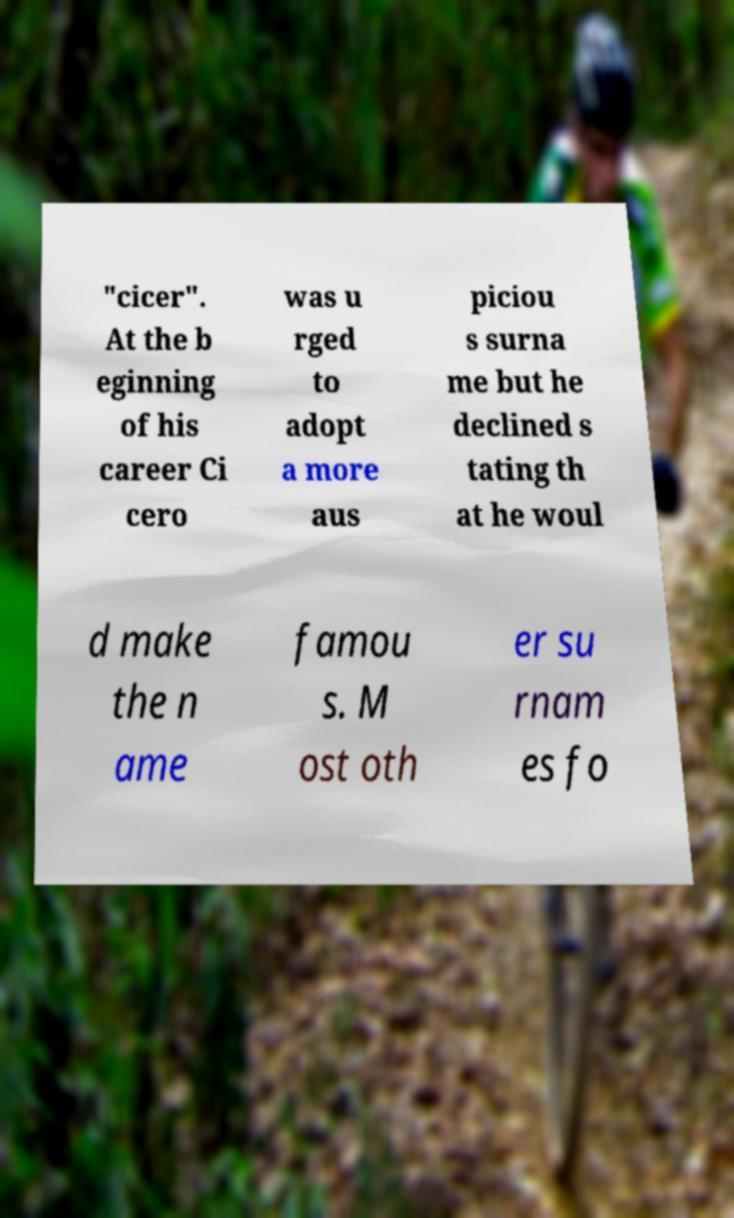What messages or text are displayed in this image? I need them in a readable, typed format. "cicer". At the b eginning of his career Ci cero was u rged to adopt a more aus piciou s surna me but he declined s tating th at he woul d make the n ame famou s. M ost oth er su rnam es fo 